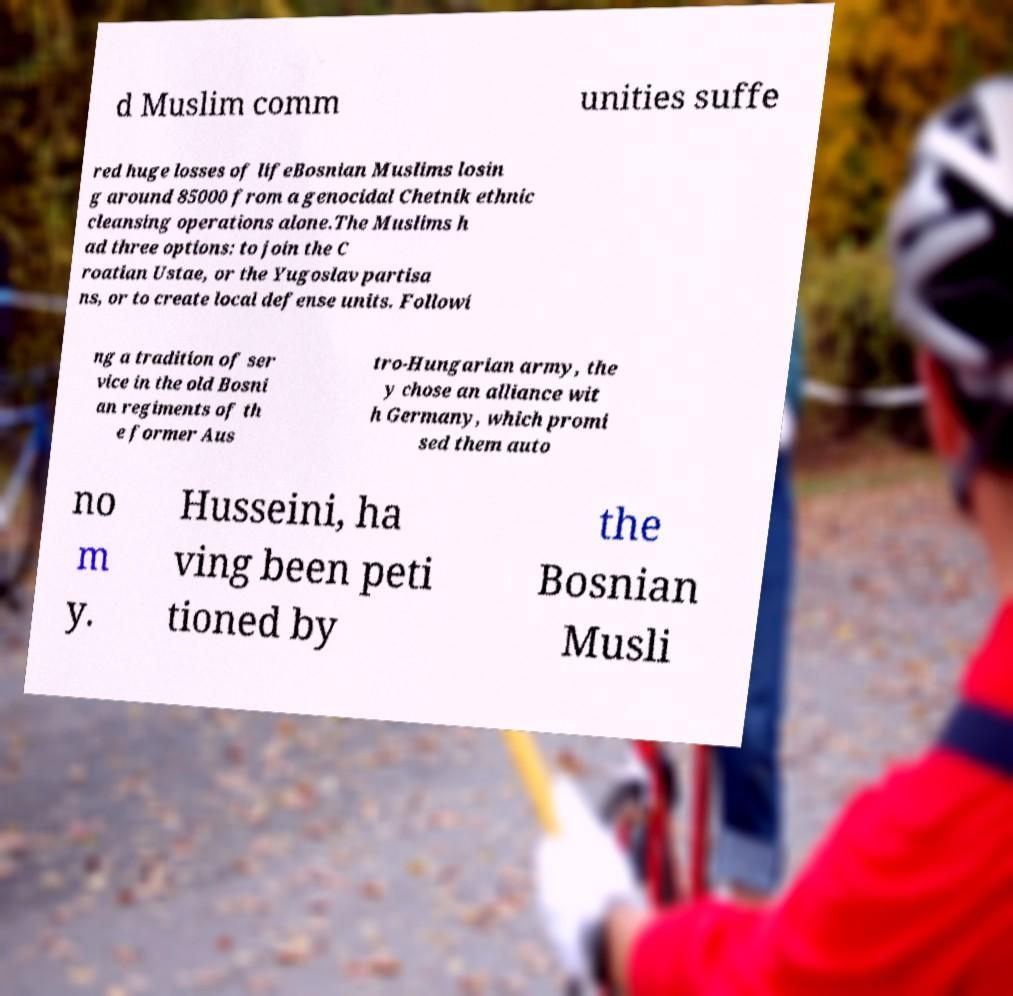Please identify and transcribe the text found in this image. d Muslim comm unities suffe red huge losses of lifeBosnian Muslims losin g around 85000 from a genocidal Chetnik ethnic cleansing operations alone.The Muslims h ad three options: to join the C roatian Ustae, or the Yugoslav partisa ns, or to create local defense units. Followi ng a tradition of ser vice in the old Bosni an regiments of th e former Aus tro-Hungarian army, the y chose an alliance wit h Germany, which promi sed them auto no m y. Husseini, ha ving been peti tioned by the Bosnian Musli 